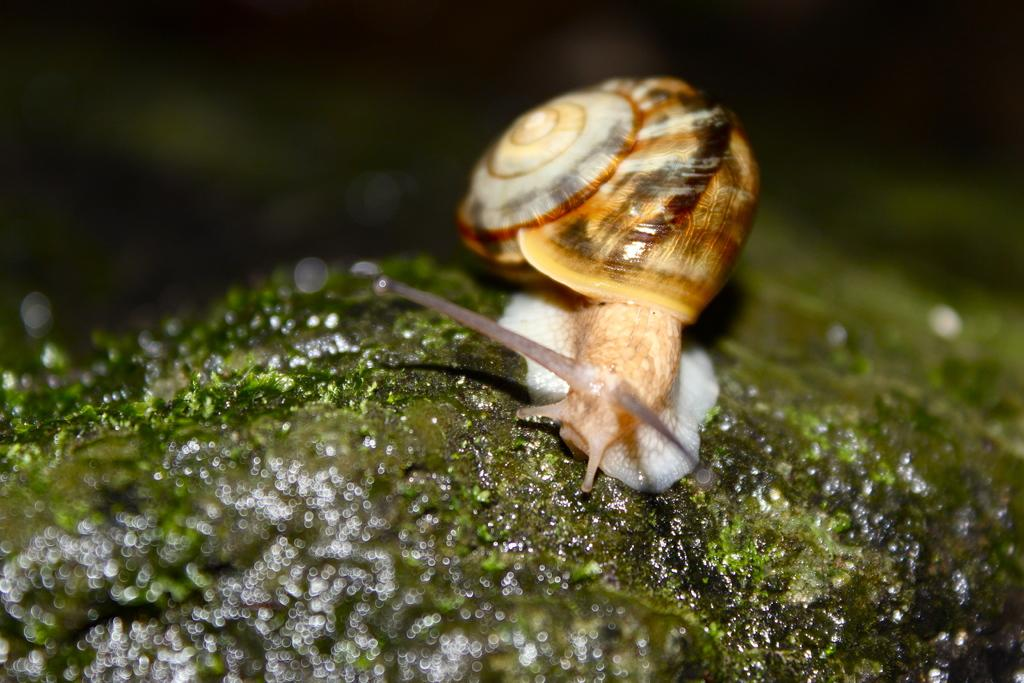What type of animal is in the image? There is a snail in the image. Where is the snail located? The snail is on a rock. What is covering the rock? The rock is covered with moss. What type of pleasure can be seen on the farm in the image? There is no farm or pleasure present in the image; it features a snail on a rock covered with moss. 